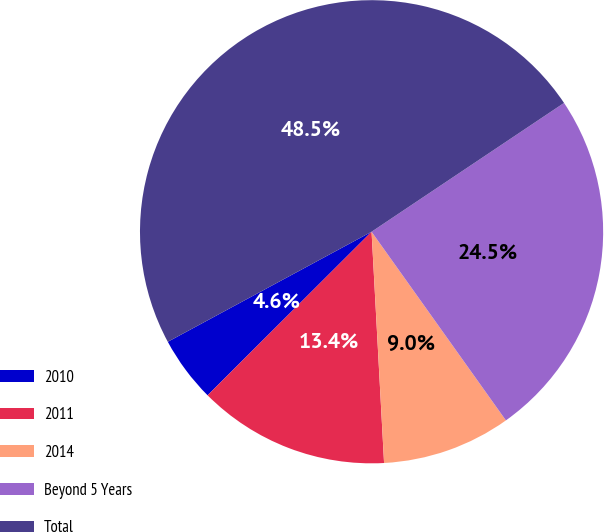Convert chart to OTSL. <chart><loc_0><loc_0><loc_500><loc_500><pie_chart><fcel>2010<fcel>2011<fcel>2014<fcel>Beyond 5 Years<fcel>Total<nl><fcel>4.6%<fcel>13.38%<fcel>8.99%<fcel>24.54%<fcel>48.5%<nl></chart> 